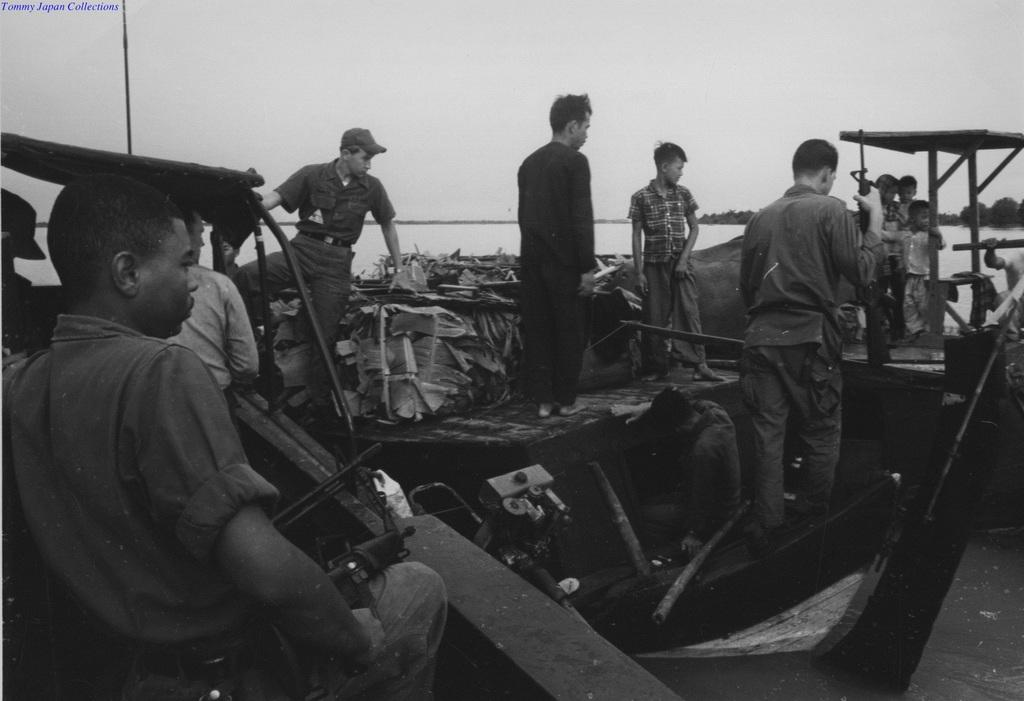How many people are in the image? There is a group of people in the image, but the exact number cannot be determined from the provided facts. What else can be seen in the image besides the group of people? There are objects visible in the image, but their specific nature cannot be determined from the provided facts. What is visible in the background of the image? In the background of the image, there is water, trees, and the sky. Is there any text present in the image? Yes, there is some text in the top left corner of the image. What type of berry is being cut with the scissors in the image? There is no berry or scissors present in the image. Is there a window visible in the image? The provided facts do not mention a window, so it cannot be determined if one is present in the image. 